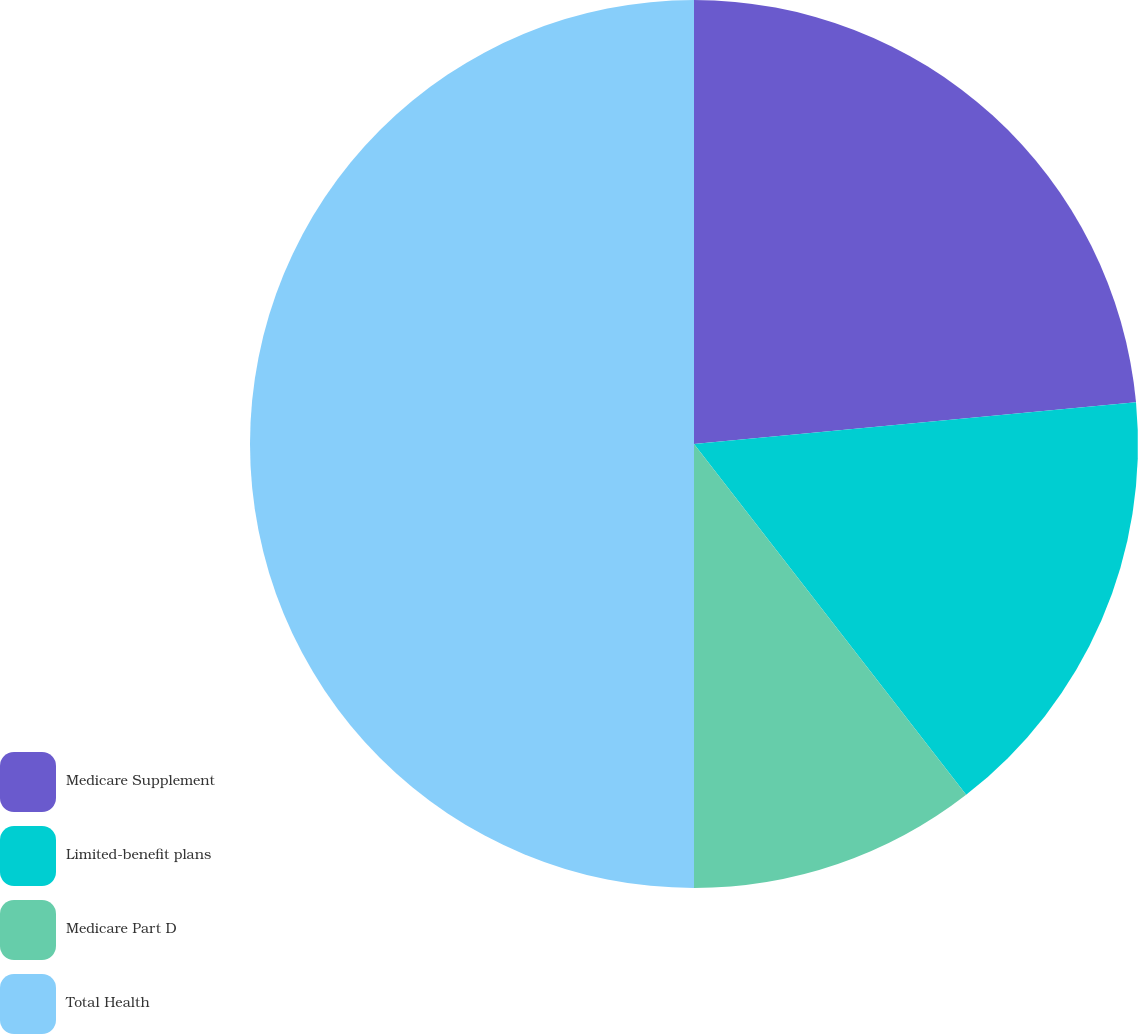Convert chart. <chart><loc_0><loc_0><loc_500><loc_500><pie_chart><fcel>Medicare Supplement<fcel>Limited-benefit plans<fcel>Medicare Part D<fcel>Total Health<nl><fcel>23.5%<fcel>16.0%<fcel>10.5%<fcel>50.0%<nl></chart> 